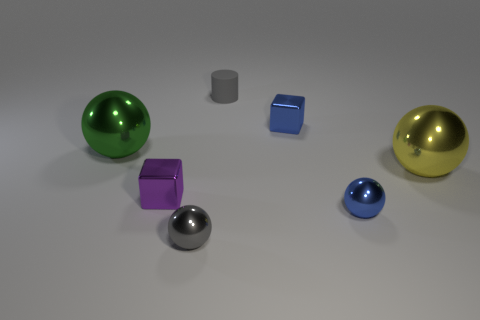There is a thing right of the small metal sphere right of the tiny gray object in front of the tiny gray matte cylinder; how big is it?
Your answer should be compact. Large. How many brown objects are blocks or small matte cylinders?
Make the answer very short. 0. There is a blue metallic thing behind the blue metal ball; does it have the same shape as the large yellow shiny thing?
Provide a short and direct response. No. Are there more large metallic balls behind the tiny rubber cylinder than big shiny objects?
Make the answer very short. No. What number of blue spheres have the same size as the yellow ball?
Your answer should be very brief. 0. The metallic ball that is the same color as the small rubber thing is what size?
Give a very brief answer. Small. What number of objects are small brown metallic blocks or tiny gray things that are behind the small purple metallic block?
Keep it short and to the point. 1. What is the color of the sphere that is behind the small blue sphere and to the right of the gray rubber thing?
Provide a short and direct response. Yellow. Is the size of the rubber object the same as the green sphere?
Offer a terse response. No. What is the color of the tiny cube behind the yellow shiny object?
Ensure brevity in your answer.  Blue. 